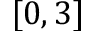<formula> <loc_0><loc_0><loc_500><loc_500>[ 0 , 3 ]</formula> 